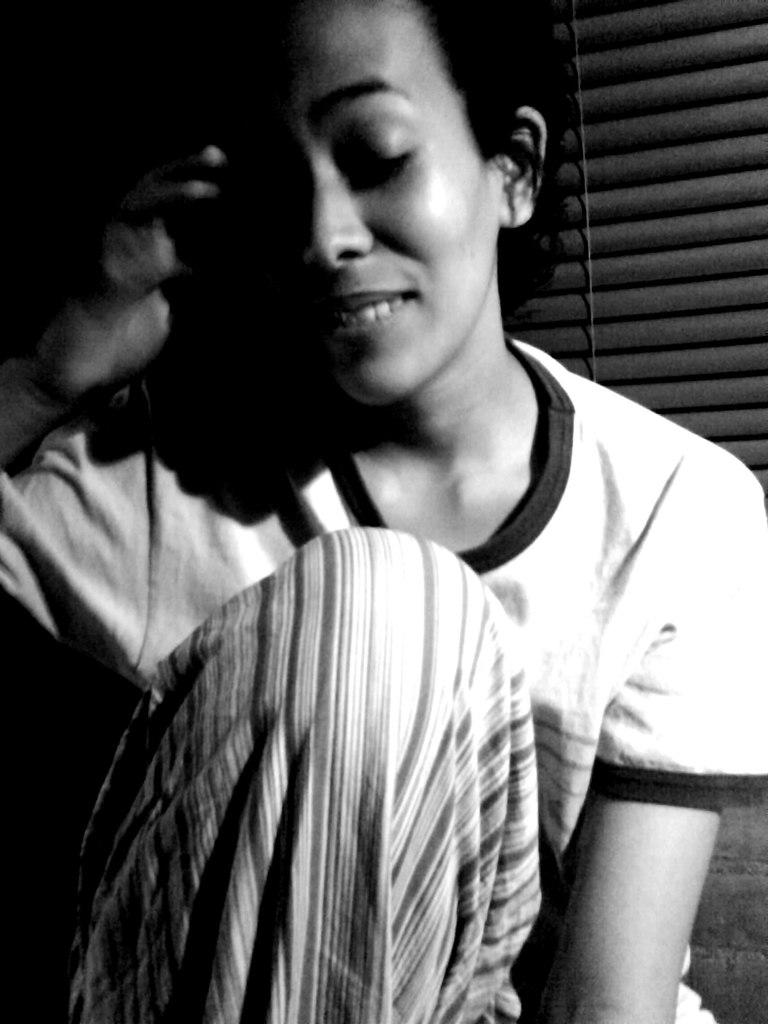What is the setting of the image? The image is likely taken inside a room. Who is the main subject in the image? There is a woman in the middle of the image. What can be seen in the background of the image? There are grills visible in the background of the image. What color is present in the background of the image? There is black color present in the background of the image. What type of yoke is being used by the woman in the image? There is no yoke present in the image. What is the texture of the floor in the image? The image does not show the floor, so it is not possible to determine its texture. 